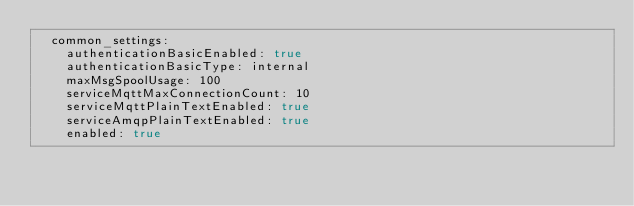Convert code to text. <code><loc_0><loc_0><loc_500><loc_500><_YAML_>  common_settings:
    authenticationBasicEnabled: true
    authenticationBasicType: internal
    maxMsgSpoolUsage: 100
    serviceMqttMaxConnectionCount: 10
    serviceMqttPlainTextEnabled: true
    serviceAmqpPlainTextEnabled: true
    enabled: true
</code> 